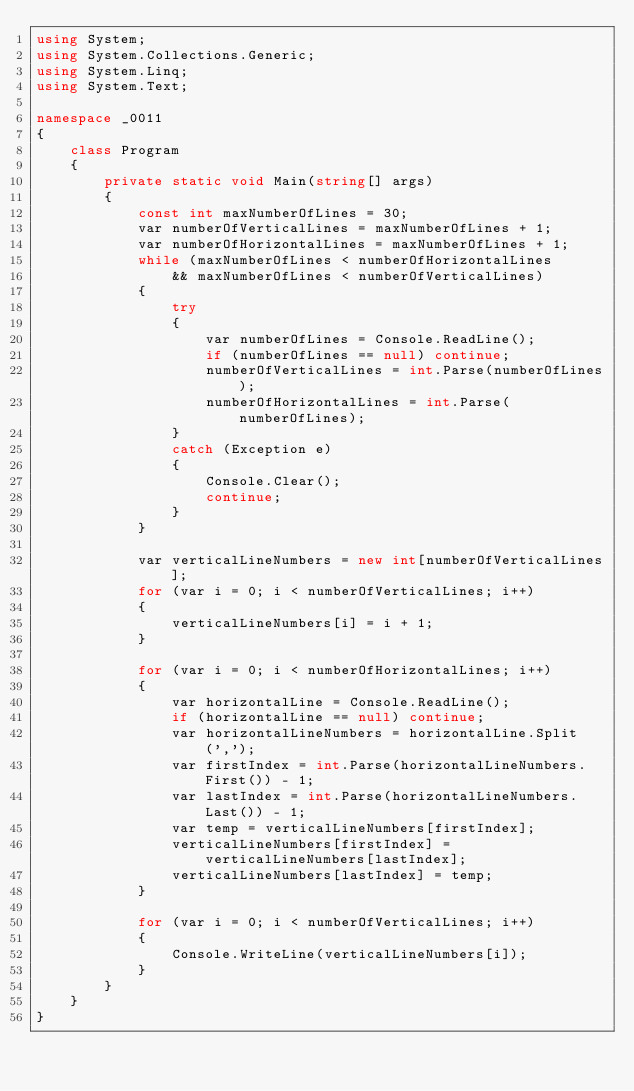Convert code to text. <code><loc_0><loc_0><loc_500><loc_500><_C#_>using System;
using System.Collections.Generic;
using System.Linq;
using System.Text;

namespace _0011
{
    class Program
    {
        private static void Main(string[] args)
        {
            const int maxNumberOfLines = 30;
            var numberOfVerticalLines = maxNumberOfLines + 1;
            var numberOfHorizontalLines = maxNumberOfLines + 1;
            while (maxNumberOfLines < numberOfHorizontalLines
                && maxNumberOfLines < numberOfVerticalLines)
            {
                try
                {
                    var numberOfLines = Console.ReadLine();
                    if (numberOfLines == null) continue;
                    numberOfVerticalLines = int.Parse(numberOfLines);
                    numberOfHorizontalLines = int.Parse(numberOfLines);
                }
                catch (Exception e)
                {
                    Console.Clear();
                    continue;
                }
            }

            var verticalLineNumbers = new int[numberOfVerticalLines];
            for (var i = 0; i < numberOfVerticalLines; i++)
            {
                verticalLineNumbers[i] = i + 1;
            }

            for (var i = 0; i < numberOfHorizontalLines; i++)
            {
                var horizontalLine = Console.ReadLine();
                if (horizontalLine == null) continue;
                var horizontalLineNumbers = horizontalLine.Split(',');
                var firstIndex = int.Parse(horizontalLineNumbers.First()) - 1;
                var lastIndex = int.Parse(horizontalLineNumbers.Last()) - 1;
                var temp = verticalLineNumbers[firstIndex];
                verticalLineNumbers[firstIndex] = verticalLineNumbers[lastIndex];
                verticalLineNumbers[lastIndex] = temp;
            }

            for (var i = 0; i < numberOfVerticalLines; i++)
            {
                Console.WriteLine(verticalLineNumbers[i]);
            }
        }
    }
}</code> 